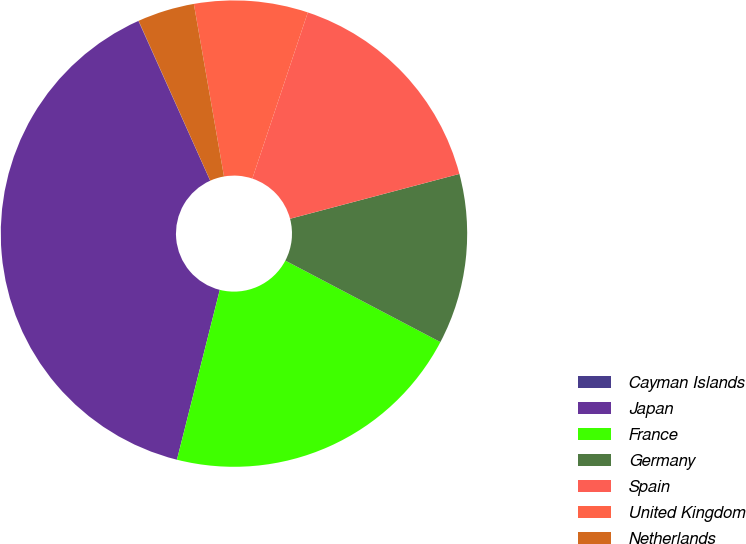Convert chart to OTSL. <chart><loc_0><loc_0><loc_500><loc_500><pie_chart><fcel>Cayman Islands<fcel>Japan<fcel>France<fcel>Germany<fcel>Spain<fcel>United Kingdom<fcel>Netherlands<nl><fcel>0.02%<fcel>39.34%<fcel>21.23%<fcel>11.82%<fcel>15.75%<fcel>7.88%<fcel>3.95%<nl></chart> 